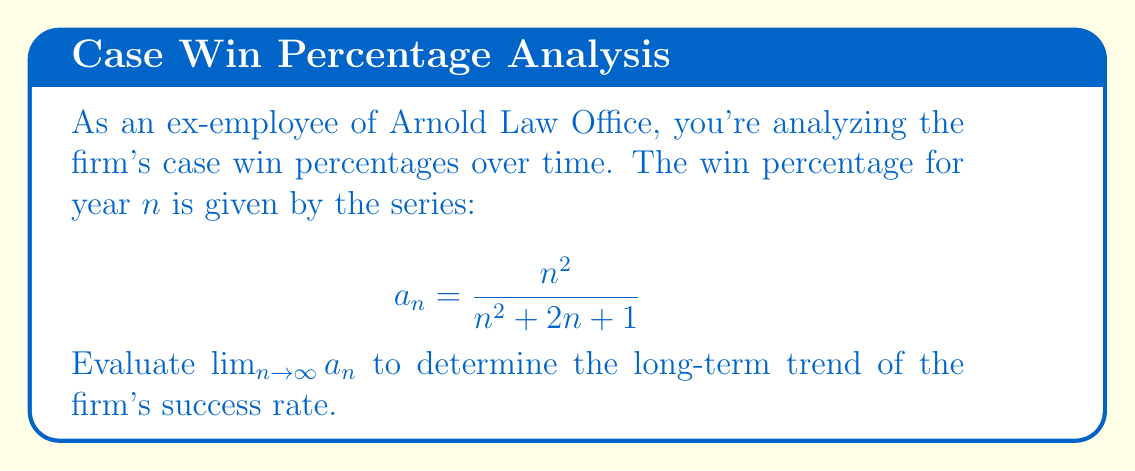Can you answer this question? To evaluate this limit, we'll follow these steps:

1) First, let's examine the general term of the series:
   $$a_n = \frac{n^2}{n^2 + 2n + 1}$$

2) To find the limit as $n$ approaches infinity, we can divide both numerator and denominator by the highest power of $n$ in the denominator, which is $n^2$:

   $$\lim_{n \to \infty} a_n = \lim_{n \to \infty} \frac{n^2}{n^2 + 2n + 1} = \lim_{n \to \infty} \frac{n^2/n^2}{(n^2 + 2n + 1)/n^2}$$

3) Simplify:
   $$\lim_{n \to \infty} \frac{1}{1 + 2/n + 1/n^2}$$

4) As $n$ approaches infinity, $1/n$ and $1/n^2$ approach 0:
   $$\lim_{n \to \infty} \frac{1}{1 + 0 + 0} = \frac{1}{1} = 1$$

Thus, the limit of the series as $n$ approaches infinity is 1, indicating that the firm's win percentage approaches 100% in the long run.
Answer: 1 